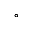Convert formula to latex. <formula><loc_0><loc_0><loc_500><loc_500>^ { \circ }</formula> 